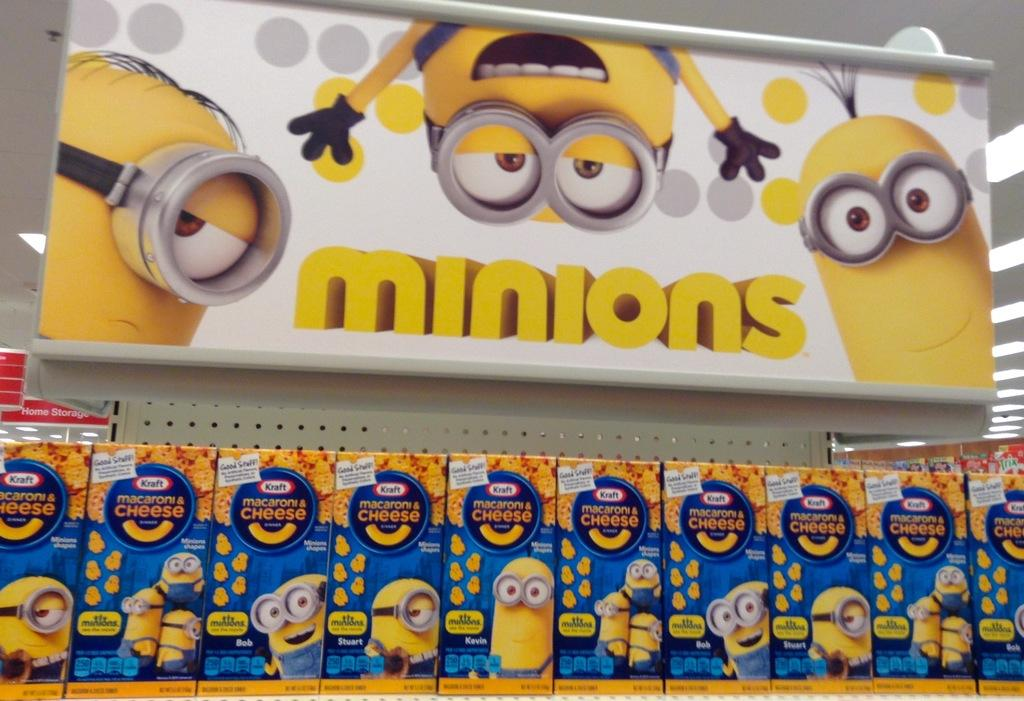What objects can be seen in the image? There are boxes and banners in the image. What else can be observed in the image? There are lights visible in the background of the image. What type of sock is being used to jump over the boxes in the image? There is no sock or jumping activity present in the image; it only features boxes, banners, and lights. 